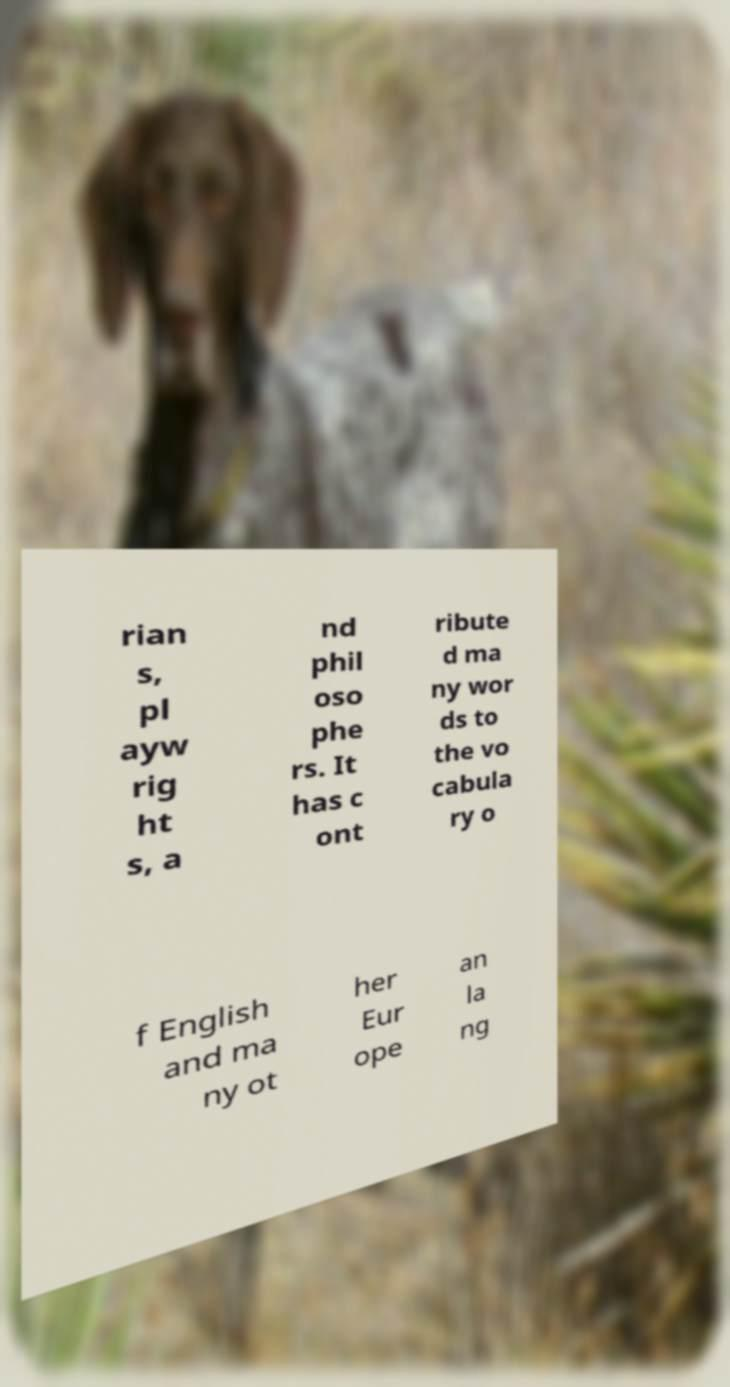Could you assist in decoding the text presented in this image and type it out clearly? rian s, pl ayw rig ht s, a nd phil oso phe rs. It has c ont ribute d ma ny wor ds to the vo cabula ry o f English and ma ny ot her Eur ope an la ng 